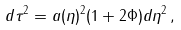<formula> <loc_0><loc_0><loc_500><loc_500>d \tau ^ { 2 } = a ( \eta ) ^ { 2 } ( 1 + 2 \Phi ) d \eta ^ { 2 } \, ,</formula> 